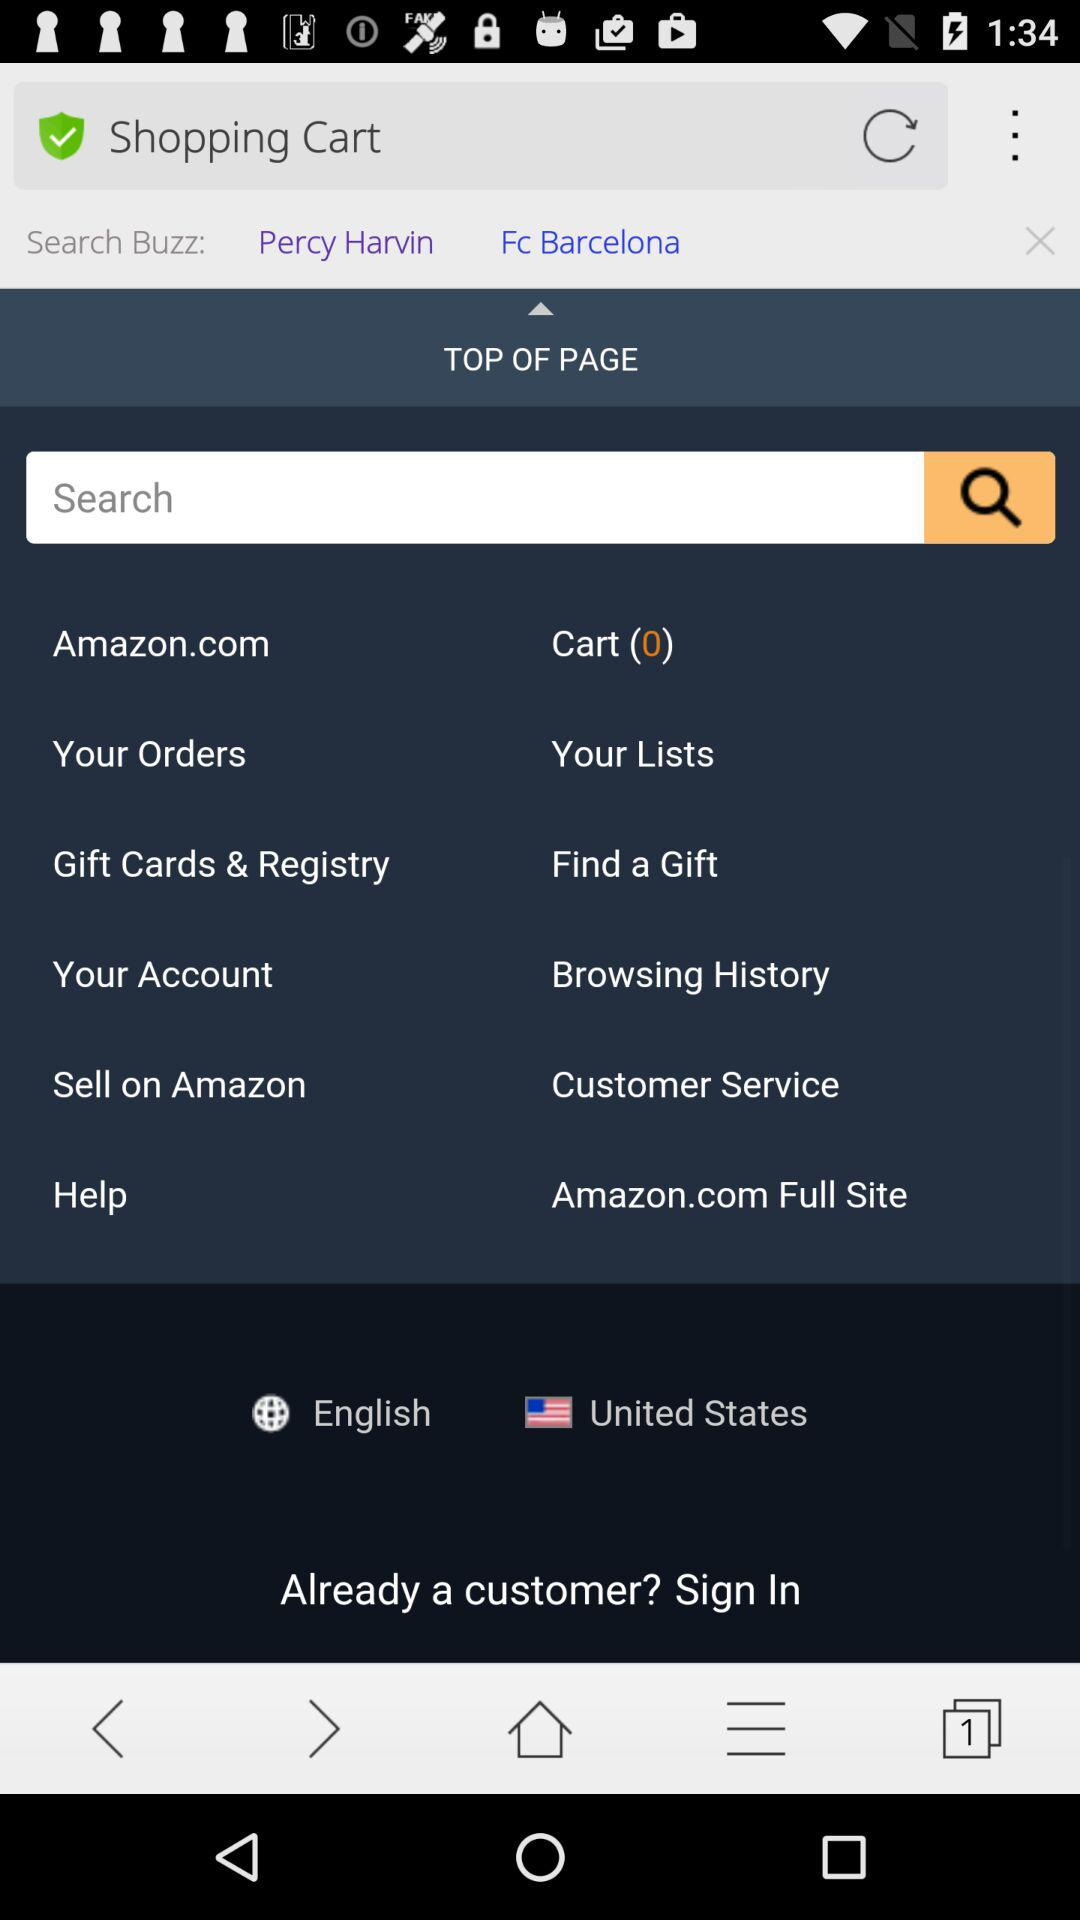What country has been selected? The selected country is "United States". 